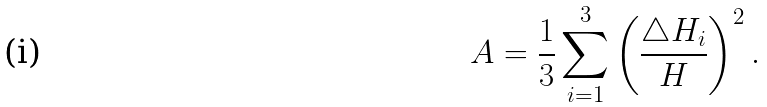<formula> <loc_0><loc_0><loc_500><loc_500>A = \frac { 1 } { 3 } \sum _ { i = 1 } ^ { 3 } \left ( \frac { \triangle H _ { i } } { H } \right ) ^ { 2 } .</formula> 